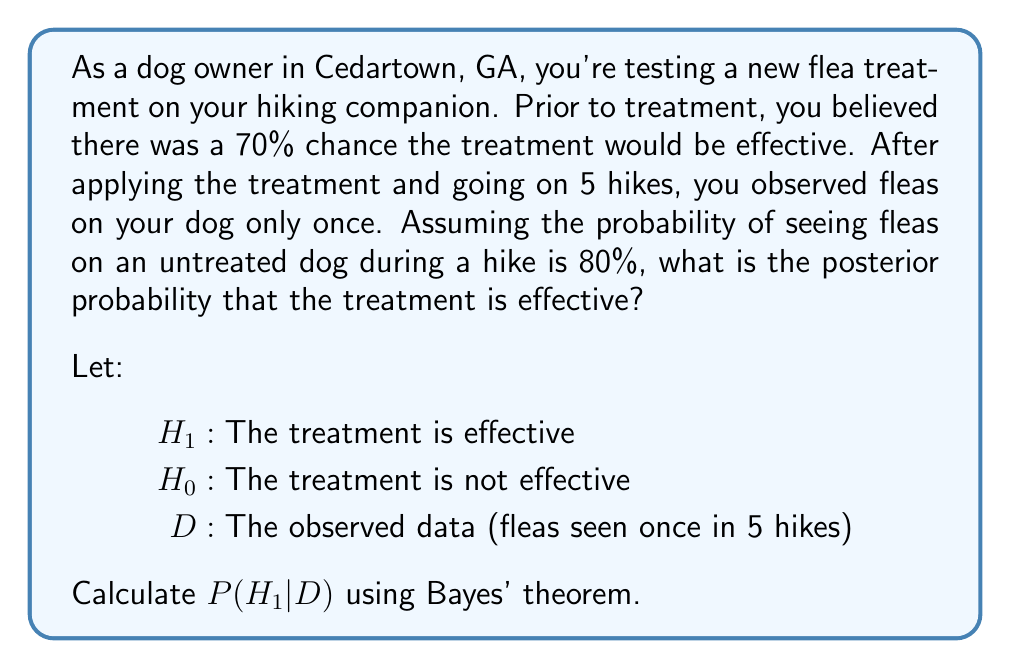Teach me how to tackle this problem. To solve this problem, we'll use Bayes' theorem:

$$P(H_1|D) = \frac{P(D|H_1)P(H_1)}{P(D|H_1)P(H_1) + P(D|H_0)P(H_0)}$$

Step 1: Identify the given probabilities
- $P(H_1) = 0.7$ (prior probability of treatment being effective)
- $P(H_0) = 1 - P(H_1) = 0.3$ (prior probability of treatment not being effective)
- $P(\text{fleas}|\text{untreated}) = 0.8$ (probability of seeing fleas on an untreated dog)

Step 2: Calculate $P(D|H_1)$ (probability of data given effective treatment)
Assuming the treatment reduces flea presence by 90%:
$P(\text{no fleas}|H_1) = 1 - (0.1 * 0.8) = 0.92$
$P(D|H_1) = \binom{5}{1}(0.08)^1(0.92)^4 = 0.3020$

Step 3: Calculate $P(D|H_0)$ (probability of data given ineffective treatment)
$P(D|H_0) = \binom{5}{1}(0.8)^1(0.2)^4 = 0.0064$

Step 4: Apply Bayes' theorem
$$P(H_1|D) = \frac{0.3020 * 0.7}{(0.3020 * 0.7) + (0.0064 * 0.3)} = 0.9930$$

Therefore, the posterior probability that the treatment is effective is approximately 0.9930 or 99.30%.
Answer: 0.9930 